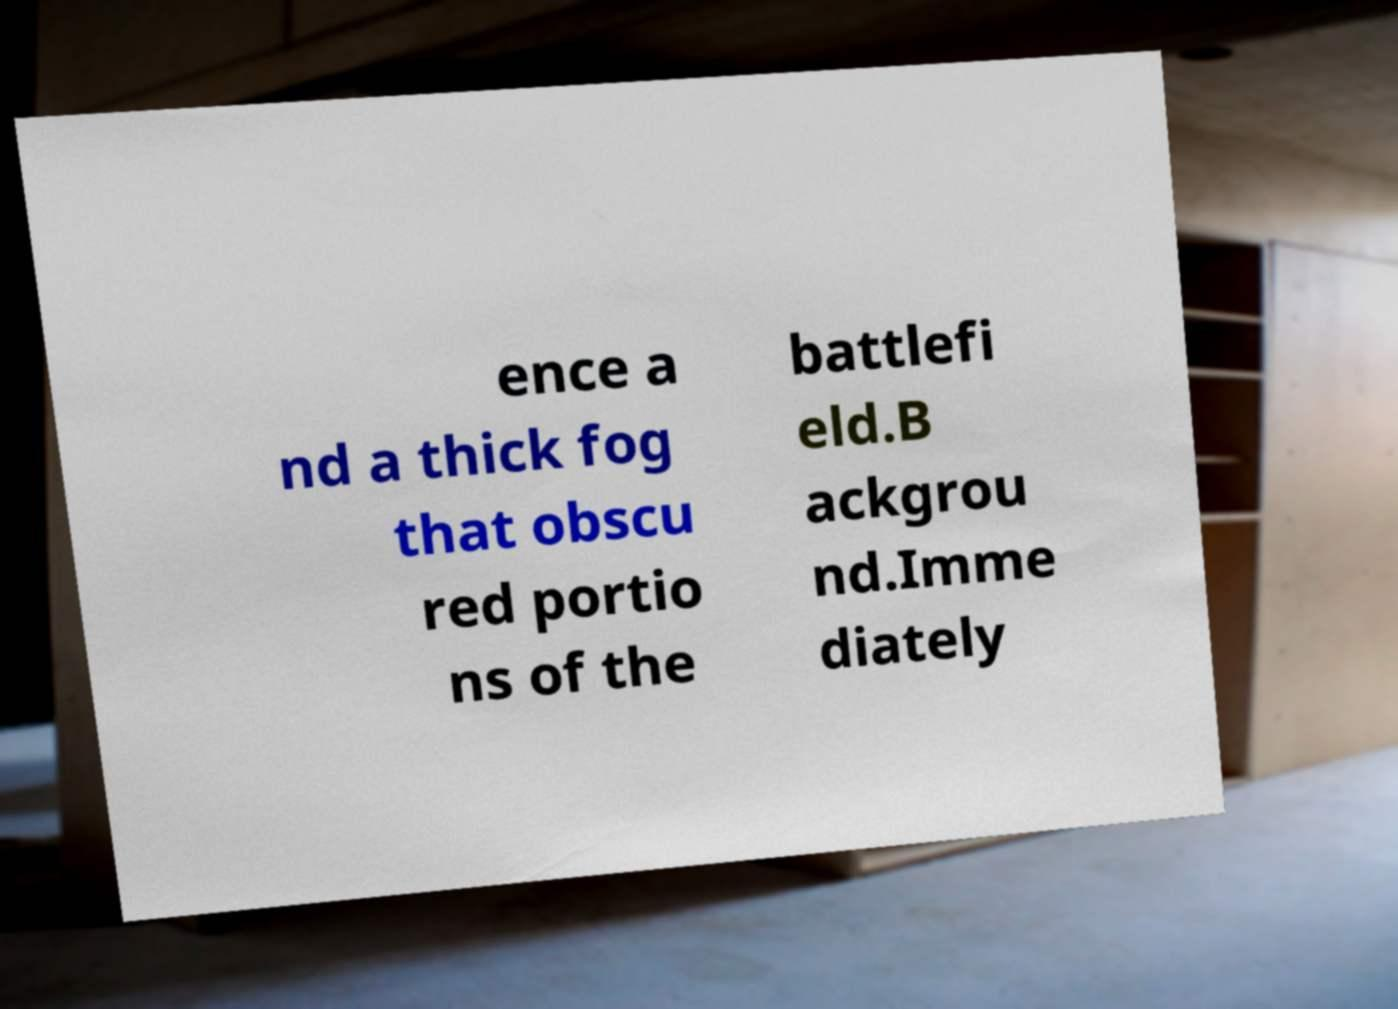Could you assist in decoding the text presented in this image and type it out clearly? ence a nd a thick fog that obscu red portio ns of the battlefi eld.B ackgrou nd.Imme diately 